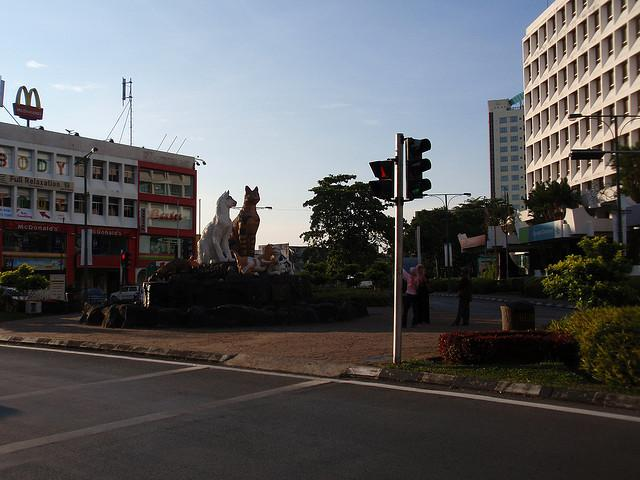What type of burger could be eaten here?

Choices:
A) none
B) big mac
C) kfc
D) whopper big mac 